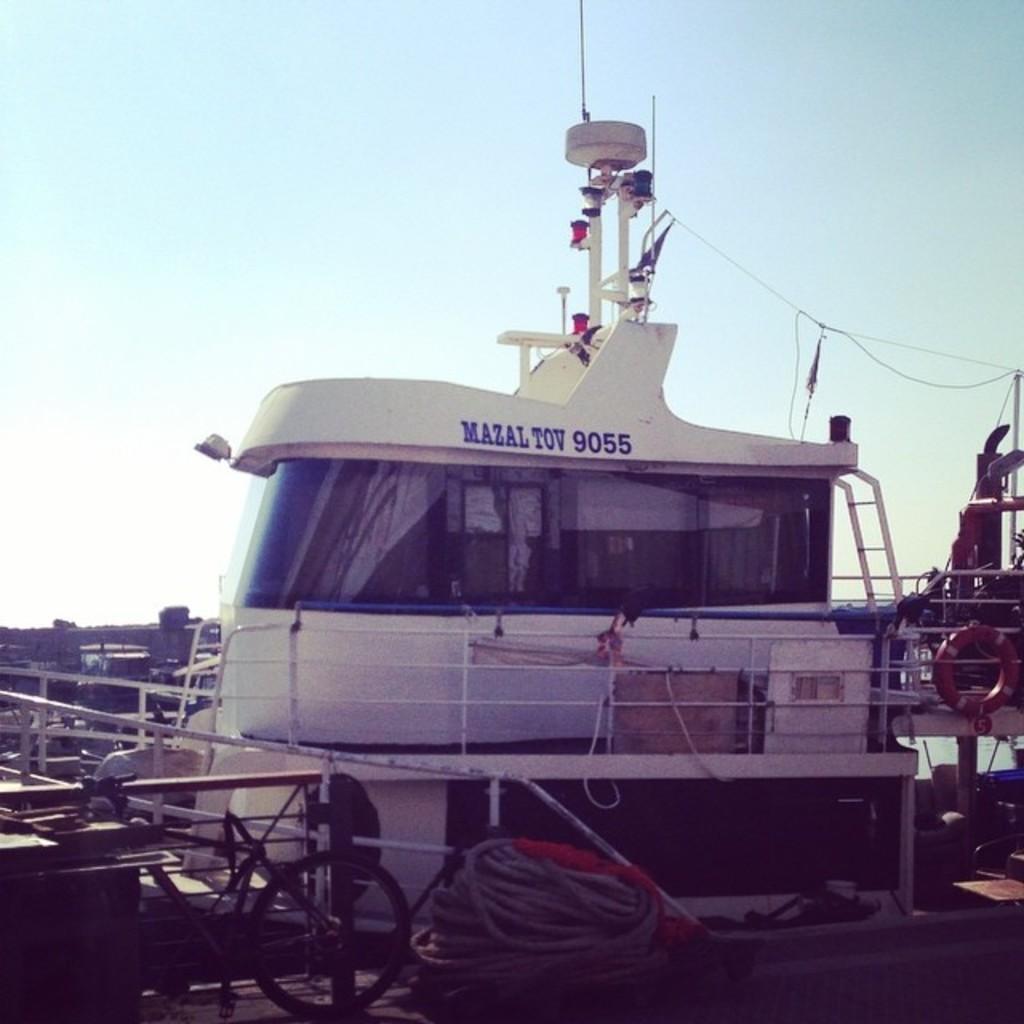Describe this image in one or two sentences. In this image I can see a ship which is in white color, background I can see sky in blue and white color. 